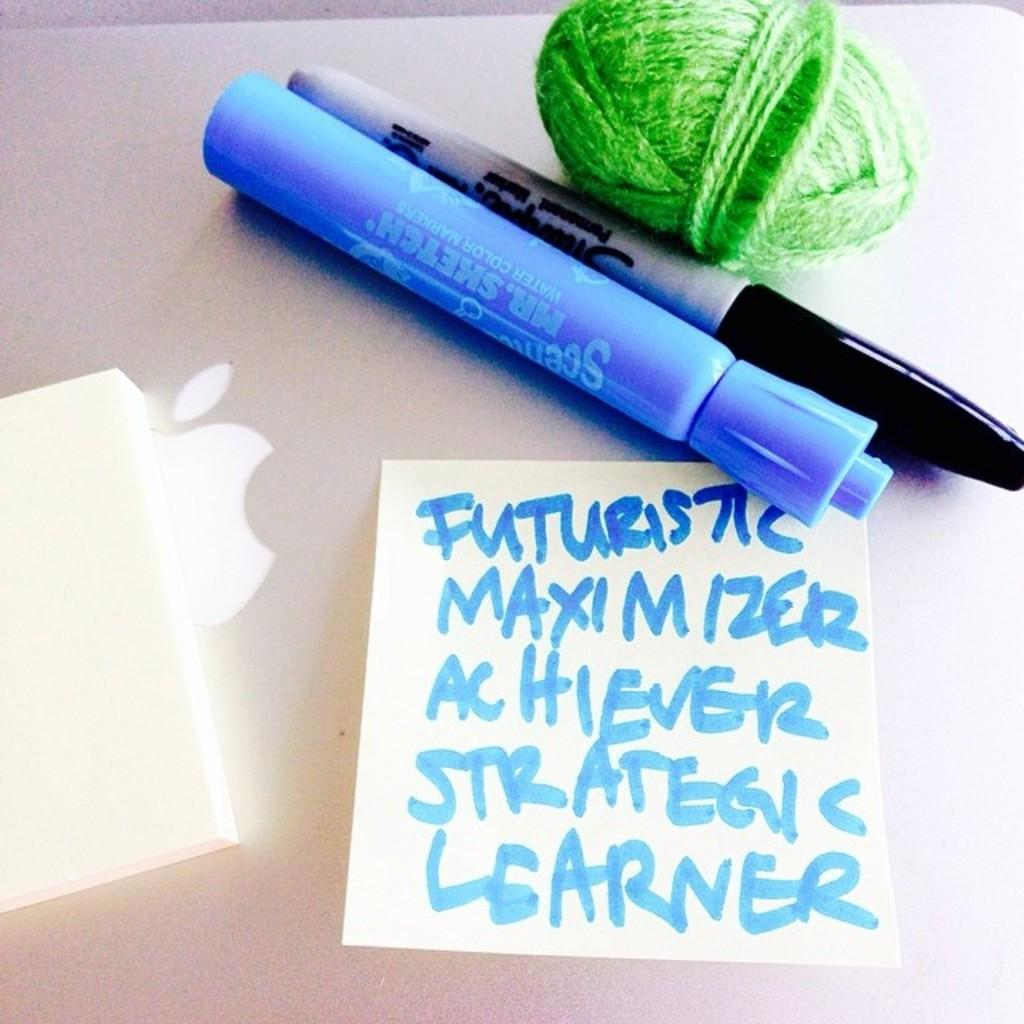What type of writing or drawing tool is present in the image? There are markers in the image. What other object can be seen in the image? There is a thread in the image. What is the laptop being used for in the image? The laptop has sticky notes on it, which suggests it is being used for note-taking or organization. What type of information is present on the paper in the image? There is text on a paper in the image. How many cattle are grazing in the background of the image? There are no cattle present in the image; it features markers, a thread, sticky notes on a laptop, and text on a paper. What type of relationship does the brother have with the person in the image? There is no brother or person present in the image; it only features markers, a thread, sticky notes on a laptop, and text on a paper. 